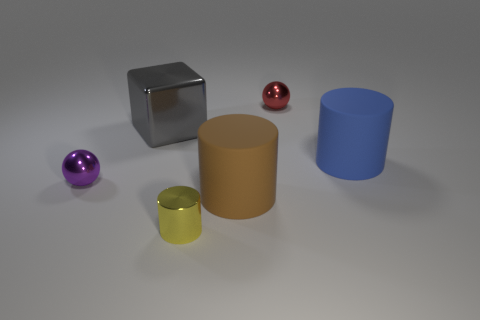Is there any object that indicates the scale of this scene? Without familiar objects to use as a reference, it's challenging to determine the exact scale of the scene. However, assuming these shapes are representative of standard objects found in a variety of sizes, the scene could be of any scale. 
Could you guess the purpose of these objects? These objects seem to be placed for a composition or visualization purpose, likely to demonstrate lighting effects and reflections on different shapes and materials for either study or artistic presentation. 